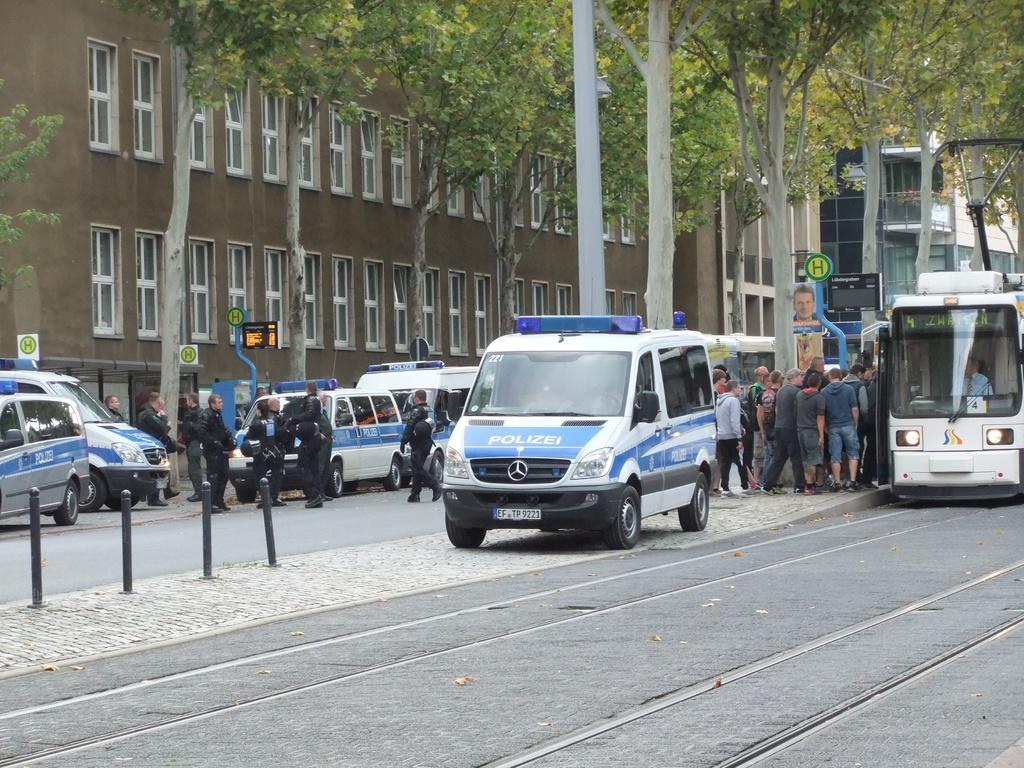<image>
Relay a brief, clear account of the picture shown. A small truck says polizei on the front and has a blue light on top. 